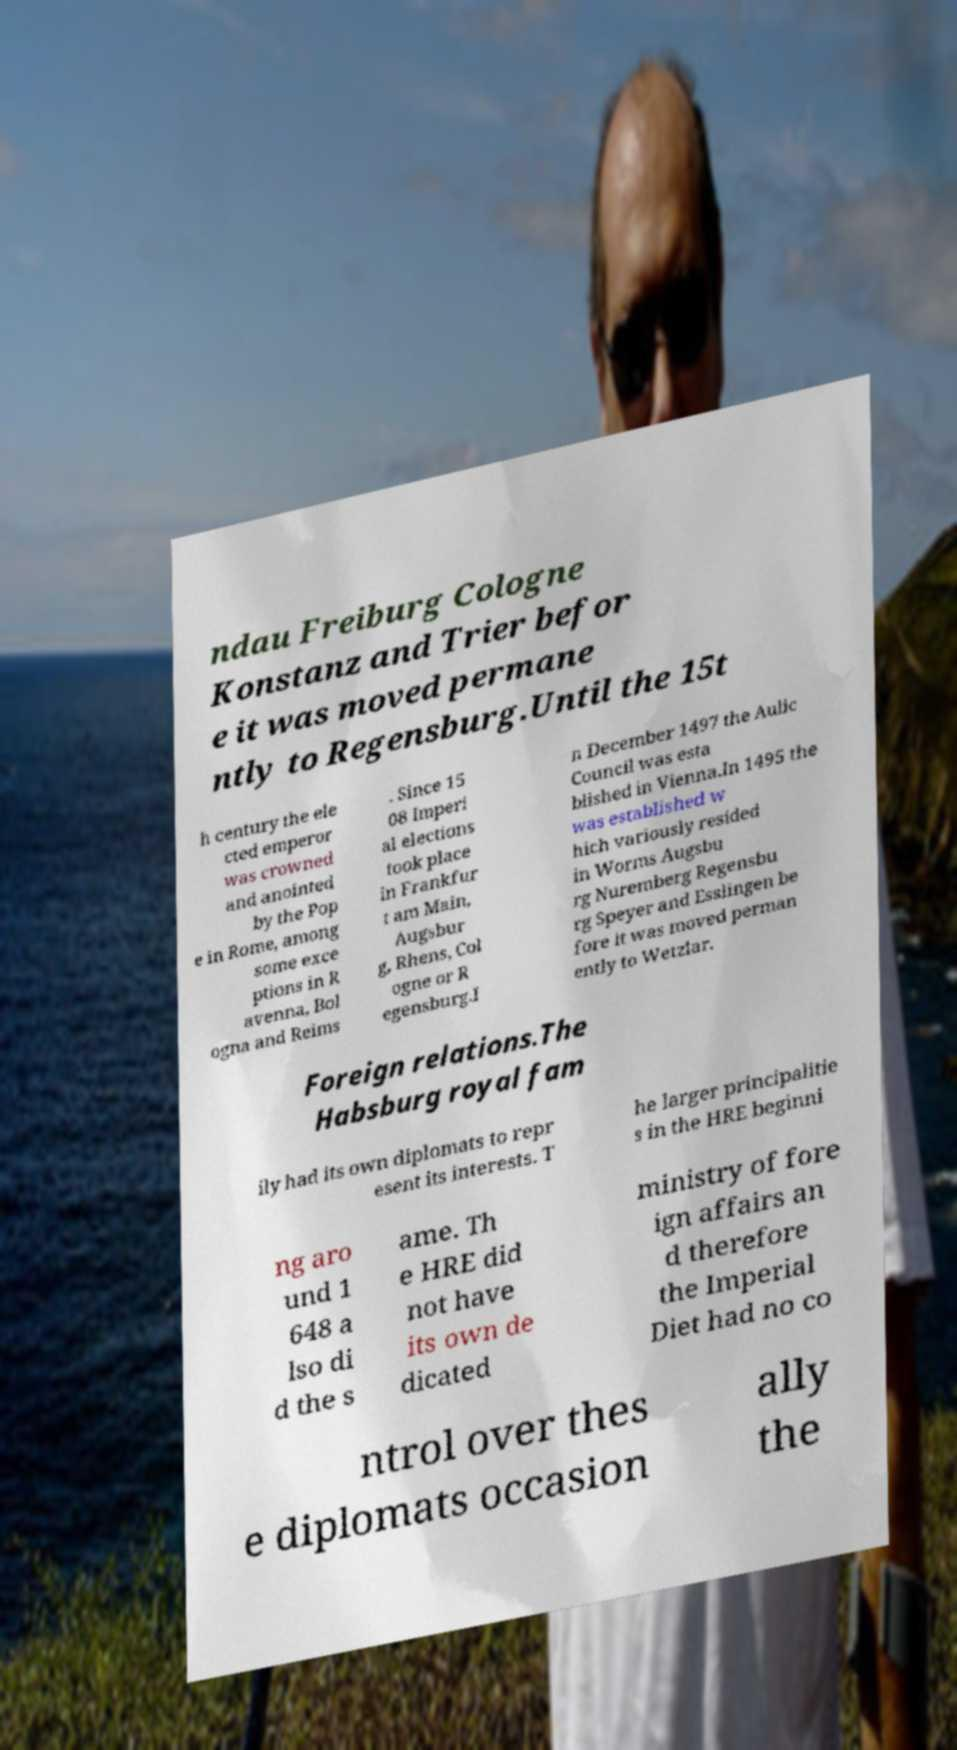Could you extract and type out the text from this image? ndau Freiburg Cologne Konstanz and Trier befor e it was moved permane ntly to Regensburg.Until the 15t h century the ele cted emperor was crowned and anointed by the Pop e in Rome, among some exce ptions in R avenna, Bol ogna and Reims . Since 15 08 Imperi al elections took place in Frankfur t am Main, Augsbur g, Rhens, Col ogne or R egensburg.I n December 1497 the Aulic Council was esta blished in Vienna.In 1495 the was established w hich variously resided in Worms Augsbu rg Nuremberg Regensbu rg Speyer and Esslingen be fore it was moved perman ently to Wetzlar. Foreign relations.The Habsburg royal fam ily had its own diplomats to repr esent its interests. T he larger principalitie s in the HRE beginni ng aro und 1 648 a lso di d the s ame. Th e HRE did not have its own de dicated ministry of fore ign affairs an d therefore the Imperial Diet had no co ntrol over thes e diplomats occasion ally the 